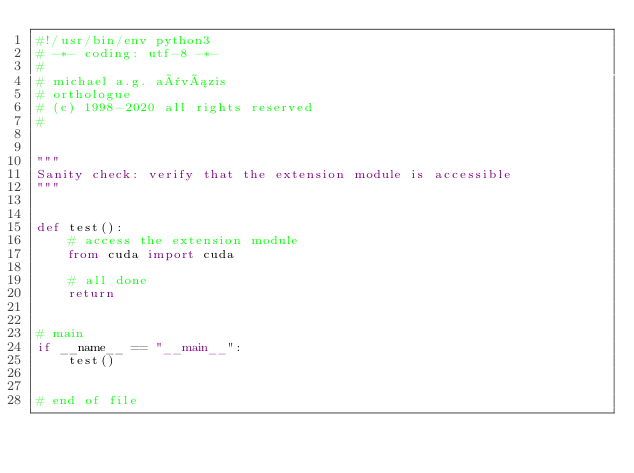<code> <loc_0><loc_0><loc_500><loc_500><_Python_>#!/usr/bin/env python3
# -*- coding: utf-8 -*-
#
# michael a.g. aïvázis
# orthologue
# (c) 1998-2020 all rights reserved
#


"""
Sanity check: verify that the extension module is accessible
"""


def test():
    # access the extension module
    from cuda import cuda

    # all done
    return


# main
if __name__ == "__main__":
    test()


# end of file
</code> 